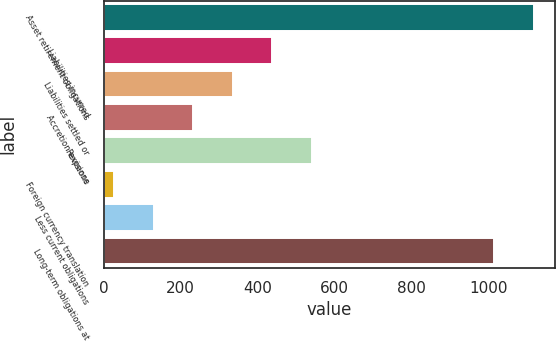<chart> <loc_0><loc_0><loc_500><loc_500><bar_chart><fcel>Asset retirement obligations<fcel>Liabilities incurred<fcel>Liabilities settled or<fcel>Accretion expense<fcel>Revisions<fcel>Foreign currency translation<fcel>Less current obligations<fcel>Long-term obligations at<nl><fcel>1118.7<fcel>438.8<fcel>336.1<fcel>233.4<fcel>541.5<fcel>28<fcel>130.7<fcel>1016<nl></chart> 